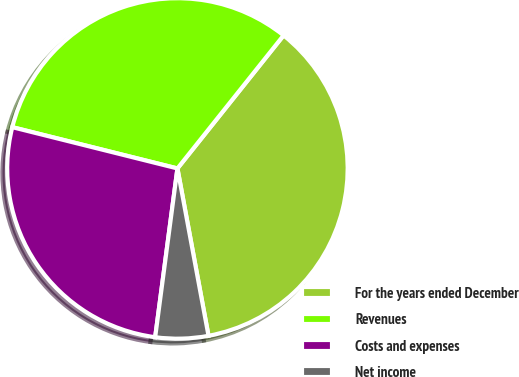Convert chart to OTSL. <chart><loc_0><loc_0><loc_500><loc_500><pie_chart><fcel>For the years ended December<fcel>Revenues<fcel>Costs and expenses<fcel>Net income<nl><fcel>36.36%<fcel>31.82%<fcel>26.81%<fcel>5.01%<nl></chart> 